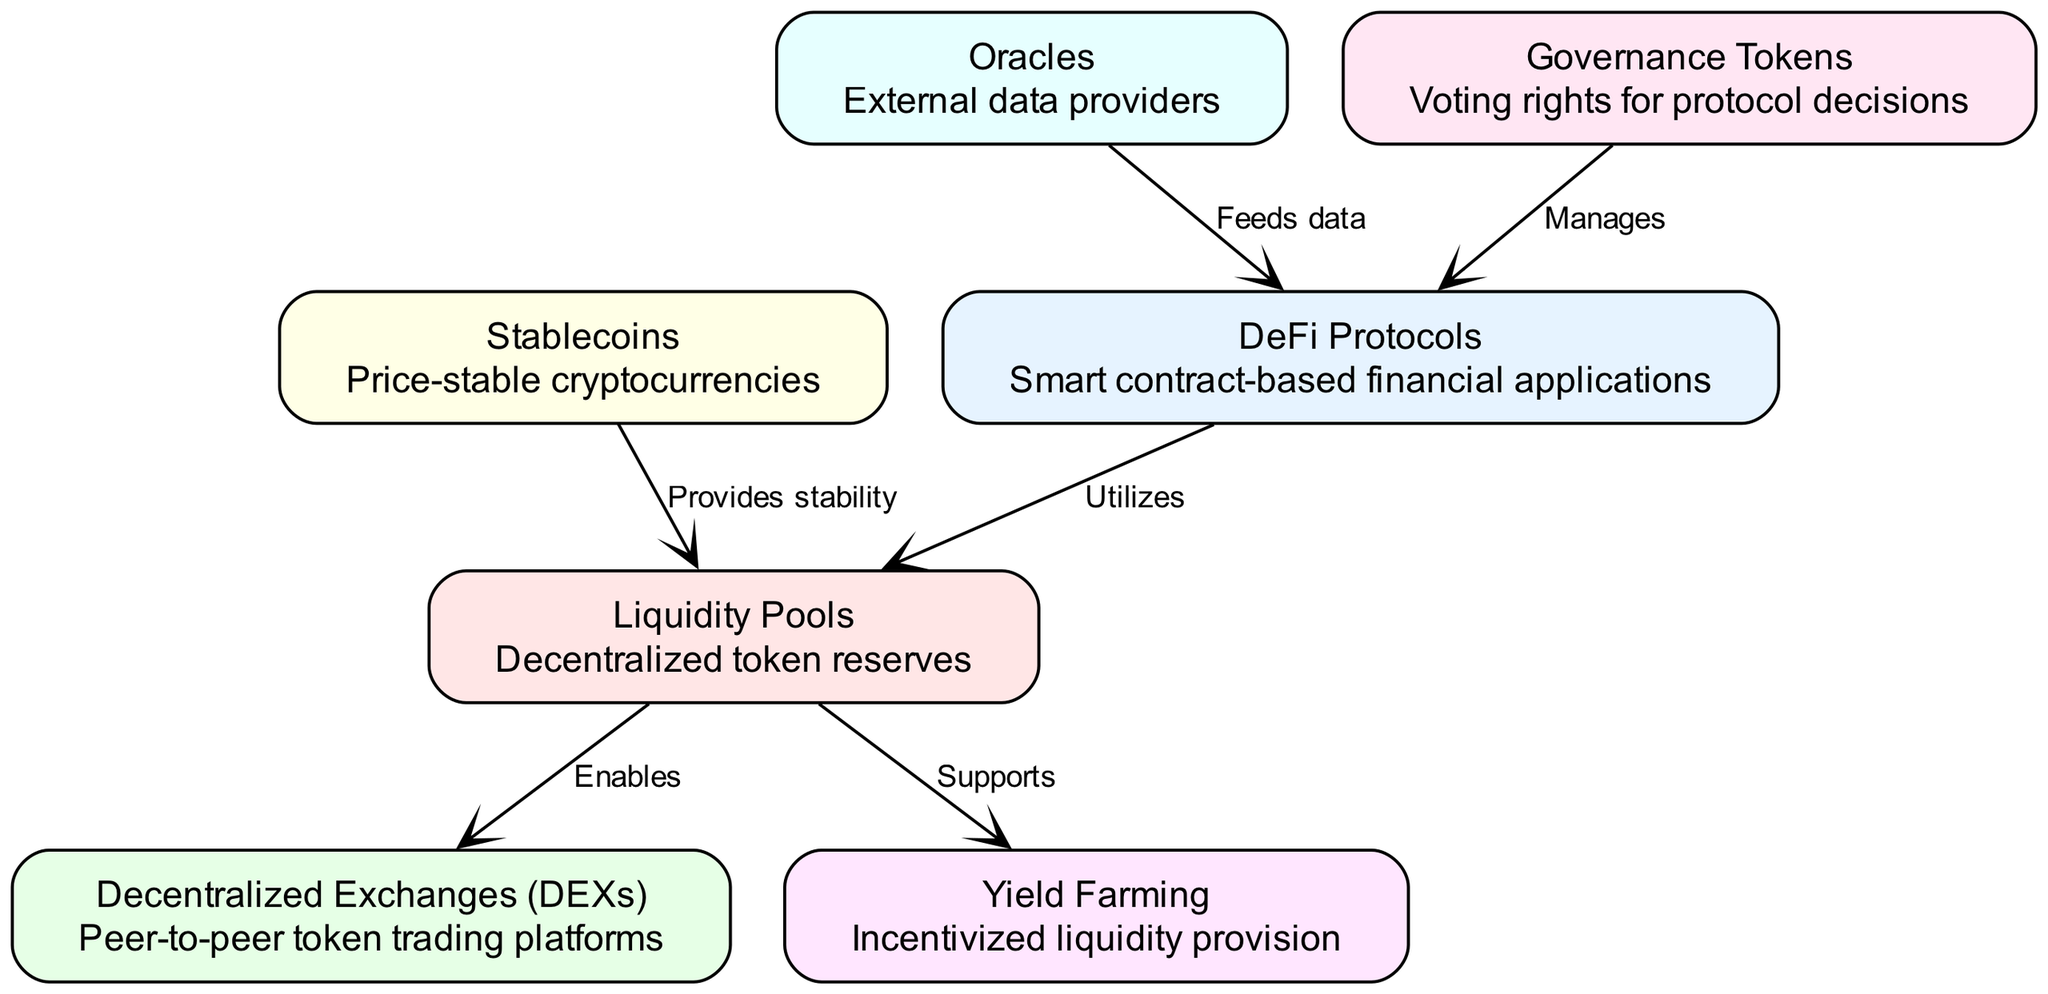What are the components of the DeFi ecosystem? The diagram presents seven main components which are: DeFi Protocols, Liquidity Pools, Decentralized Exchanges (DEXs), Yield Farming, Stablecoins, Oracles, and Governance Tokens.
Answer: DeFi Protocols, Liquidity Pools, Decentralized Exchanges, Yield Farming, Stablecoins, Oracles, Governance Tokens Which component provides stability to Liquidity Pools? The diagram indicates that Stablecoins provide stability to Liquidity Pools, as per the labeled edge between Stablecoins and Liquidity Pools.
Answer: Stablecoins How many edges are there in the diagram? By counting the connections (edges) between the nodes, there are a total of six edges connecting the various components.
Answer: Six What role do Oracles play in the DeFi Protocols? The diagram specifies that Oracles feed data to DeFi Protocols, as indicated by the directed edge from Oracles to DeFi Protocols labeled "Feeds data."
Answer: Feeds data Which component supports Yield Farming? According to the diagram, Liquidity Pools support Yield Farming as reflected in the edge labeled "Supports."
Answer: Liquidity Pools What is the relationship between Governance Tokens and DeFi Protocols? The diagram shows that Governance Tokens manage DeFi Protocols, as indicated by the directional edge labeled "Manages."
Answer: Manages Do Liquidity Pools enable Decentralized Exchanges? Yes, the edge connecting Liquidity Pools to Decentralized Exchanges is labeled "Enables," indicating that Liquidity Pools facilitate the operation of Decentralized Exchanges.
Answer: Yes How are DeFi Protocols and Oracles connected? The connection between DeFi Protocols and Oracles is established by the edge that indicates Oracles feed data to DeFi Protocols, demonstrating their interdependency.
Answer: Feeds data 